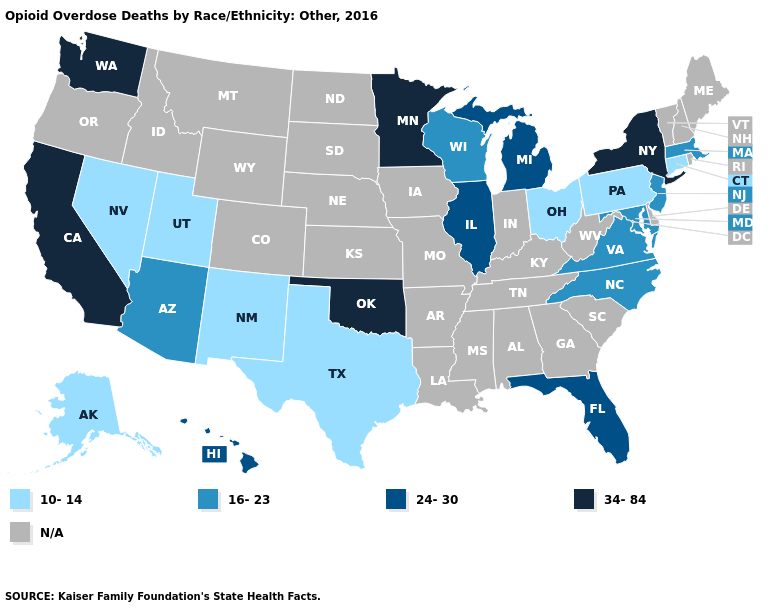Does Ohio have the lowest value in the MidWest?
Keep it brief. Yes. What is the value of Wisconsin?
Answer briefly. 16-23. Name the states that have a value in the range 34-84?
Concise answer only. California, Minnesota, New York, Oklahoma, Washington. What is the value of Florida?
Give a very brief answer. 24-30. Among the states that border Colorado , which have the highest value?
Write a very short answer. Oklahoma. Does Washington have the highest value in the USA?
Write a very short answer. Yes. Is the legend a continuous bar?
Be succinct. No. What is the value of Florida?
Short answer required. 24-30. Is the legend a continuous bar?
Concise answer only. No. Name the states that have a value in the range 16-23?
Short answer required. Arizona, Maryland, Massachusetts, New Jersey, North Carolina, Virginia, Wisconsin. Among the states that border Wisconsin , which have the highest value?
Answer briefly. Minnesota. Does the first symbol in the legend represent the smallest category?
Concise answer only. Yes. Name the states that have a value in the range 10-14?
Short answer required. Alaska, Connecticut, Nevada, New Mexico, Ohio, Pennsylvania, Texas, Utah. Name the states that have a value in the range 24-30?
Give a very brief answer. Florida, Hawaii, Illinois, Michigan. Does Wisconsin have the highest value in the USA?
Short answer required. No. 